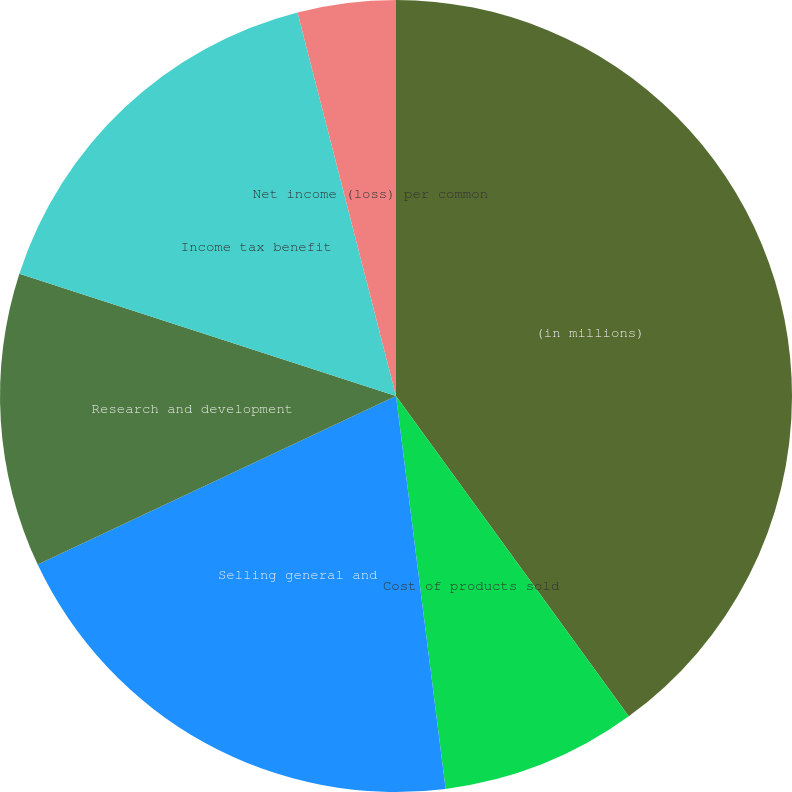<chart> <loc_0><loc_0><loc_500><loc_500><pie_chart><fcel>(in millions)<fcel>Cost of products sold<fcel>Selling general and<fcel>Research and development<fcel>Income tax benefit<fcel>Net income (loss) per common<nl><fcel>40.0%<fcel>8.0%<fcel>20.0%<fcel>12.0%<fcel>16.0%<fcel>4.0%<nl></chart> 